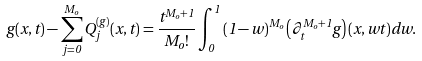Convert formula to latex. <formula><loc_0><loc_0><loc_500><loc_500>g ( x , t ) - \sum _ { j = 0 } ^ { M _ { o } } Q _ { j } ^ { ( g ) } ( x , t ) = \frac { t ^ { M _ { o } + 1 } } { M _ { o } ! } \int _ { 0 } ^ { 1 } { ( 1 - w ) } ^ { M _ { o } } \left ( \partial _ { t } ^ { M _ { o } + 1 } g \right ) ( x , w t ) d w .</formula> 